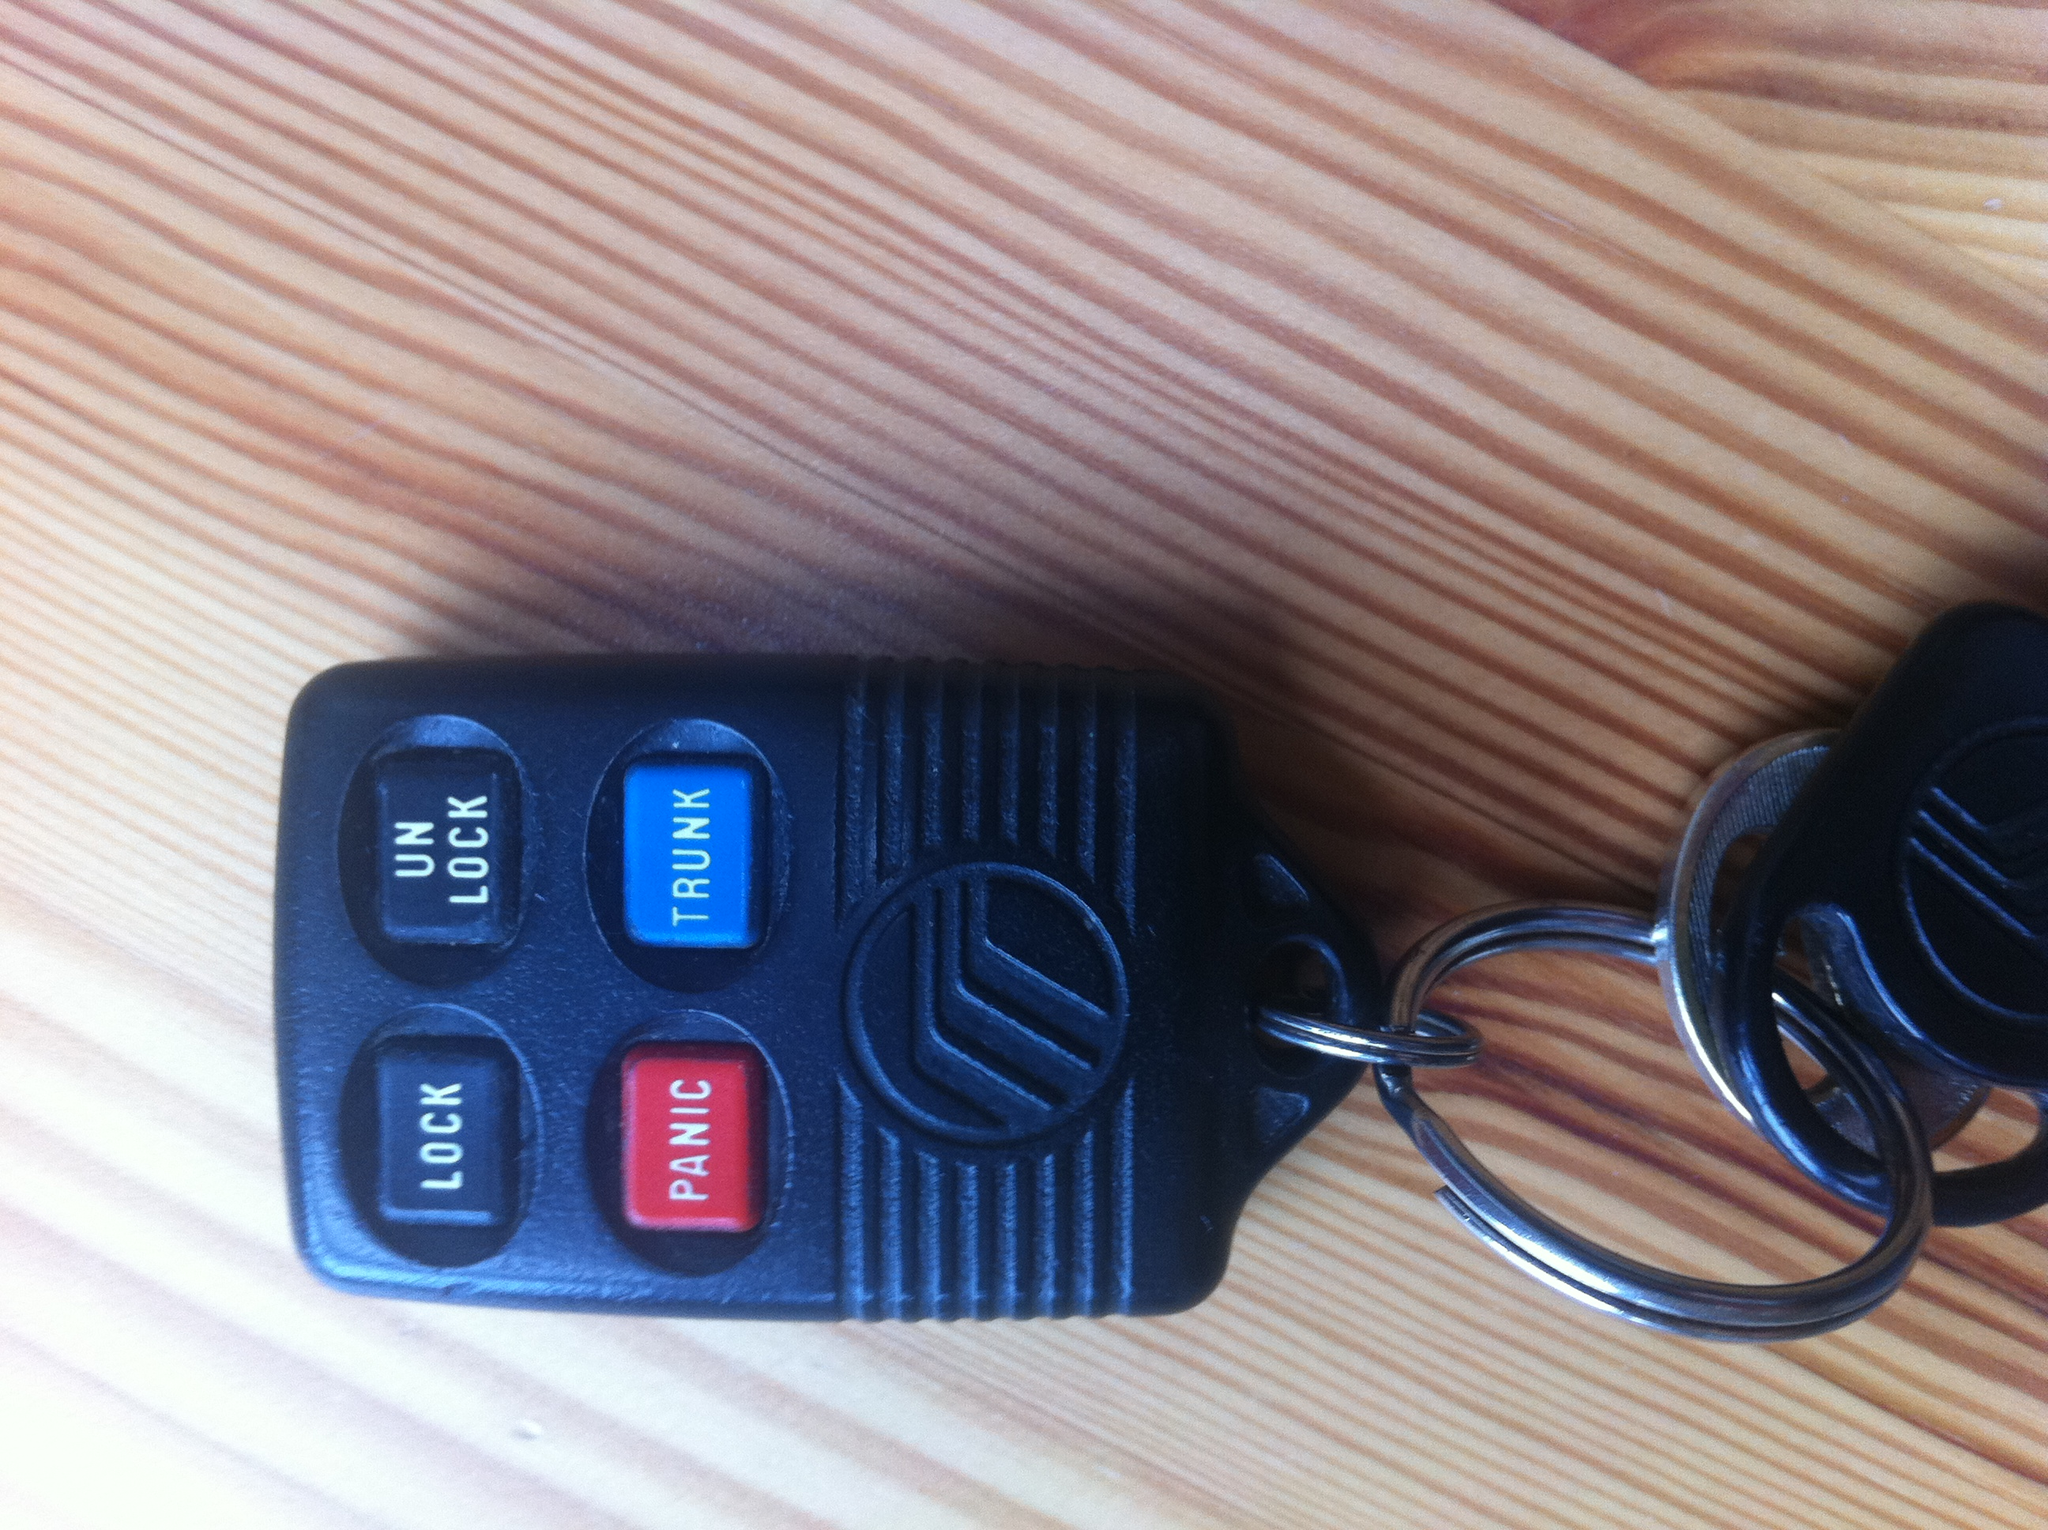What do the button say on these keys? The buttons on these keys say: 'LOCK', 'UNLOCK', 'PANIC', and 'TRUNK'. 